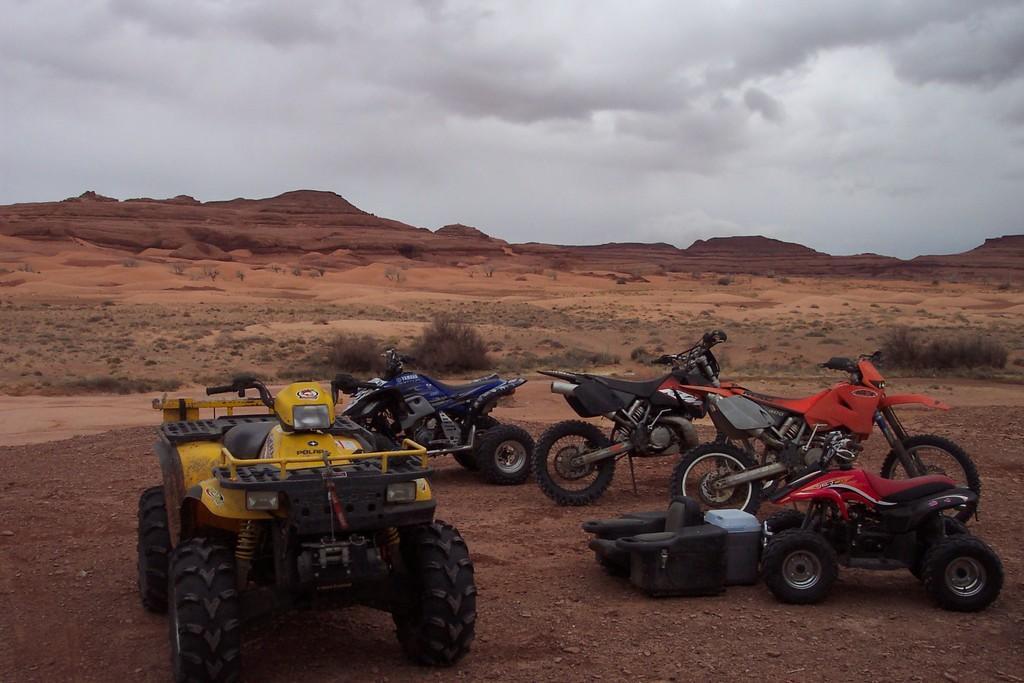Describe this image in one or two sentences. In this picture we can see terrain vehicles and three bikes in the front, in the background there are some plants, we can see the sky and clouds at the top of the picture, at the bottom there are some stones. 